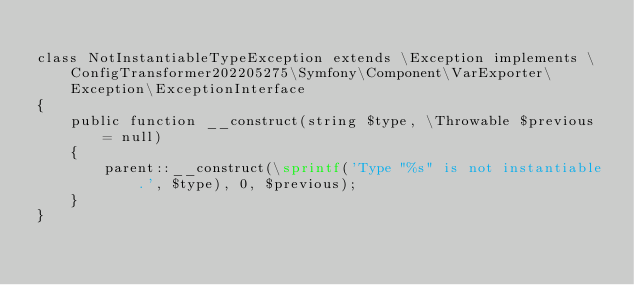Convert code to text. <code><loc_0><loc_0><loc_500><loc_500><_PHP_>
class NotInstantiableTypeException extends \Exception implements \ConfigTransformer202205275\Symfony\Component\VarExporter\Exception\ExceptionInterface
{
    public function __construct(string $type, \Throwable $previous = null)
    {
        parent::__construct(\sprintf('Type "%s" is not instantiable.', $type), 0, $previous);
    }
}
</code> 